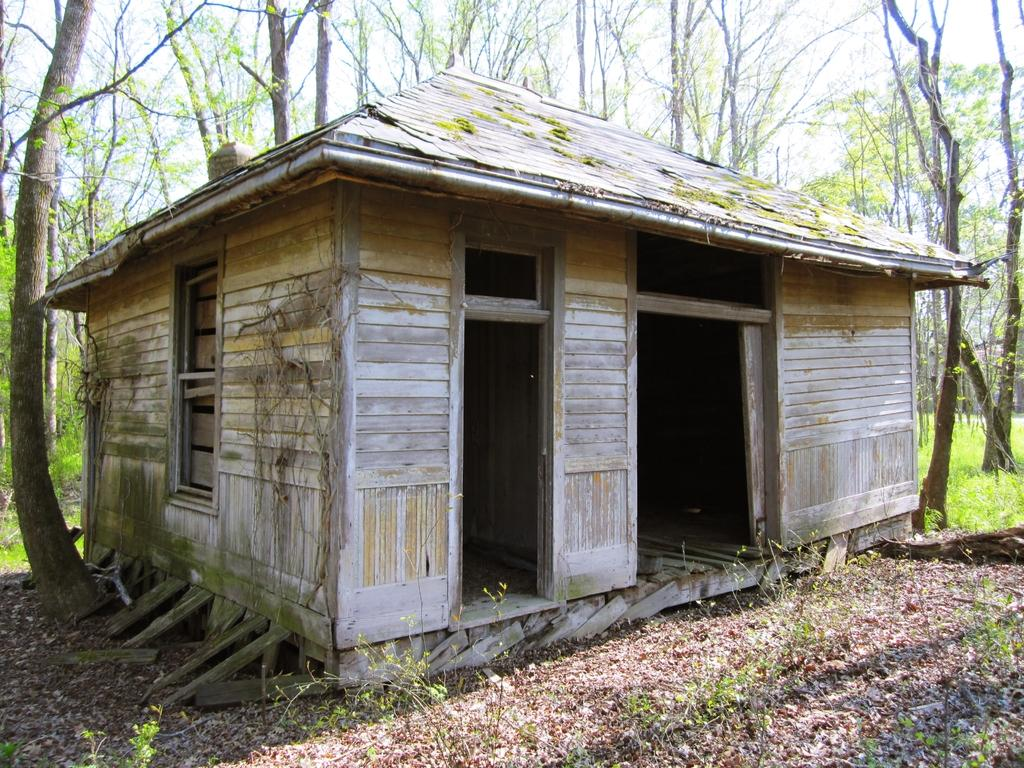What is the main subject in the center of the image? There is a house in the center of the image. What can be seen in the background of the image? There are trees in the background of the image. What type of vegetation is present on the ground in the image? There is grass on the ground in the image. How many clocks are hanging on the trees in the image? There are no clocks visible on the trees in the image. What type of women can be seen walking through the grass in the image? There are no women present in the image; it only features a house, trees, and grass. 